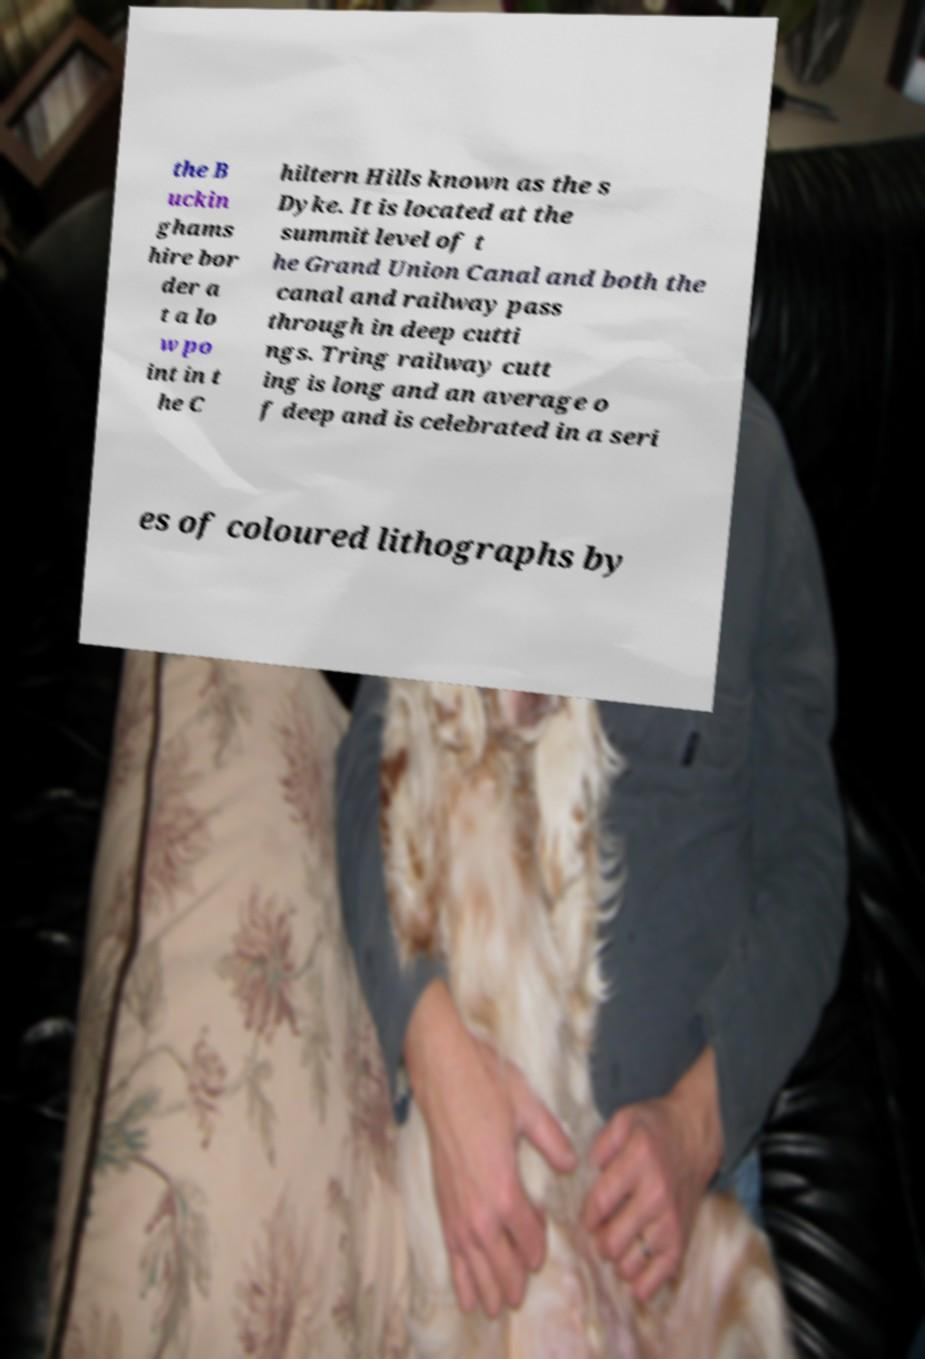Can you read and provide the text displayed in the image?This photo seems to have some interesting text. Can you extract and type it out for me? the B uckin ghams hire bor der a t a lo w po int in t he C hiltern Hills known as the s Dyke. It is located at the summit level of t he Grand Union Canal and both the canal and railway pass through in deep cutti ngs. Tring railway cutt ing is long and an average o f deep and is celebrated in a seri es of coloured lithographs by 